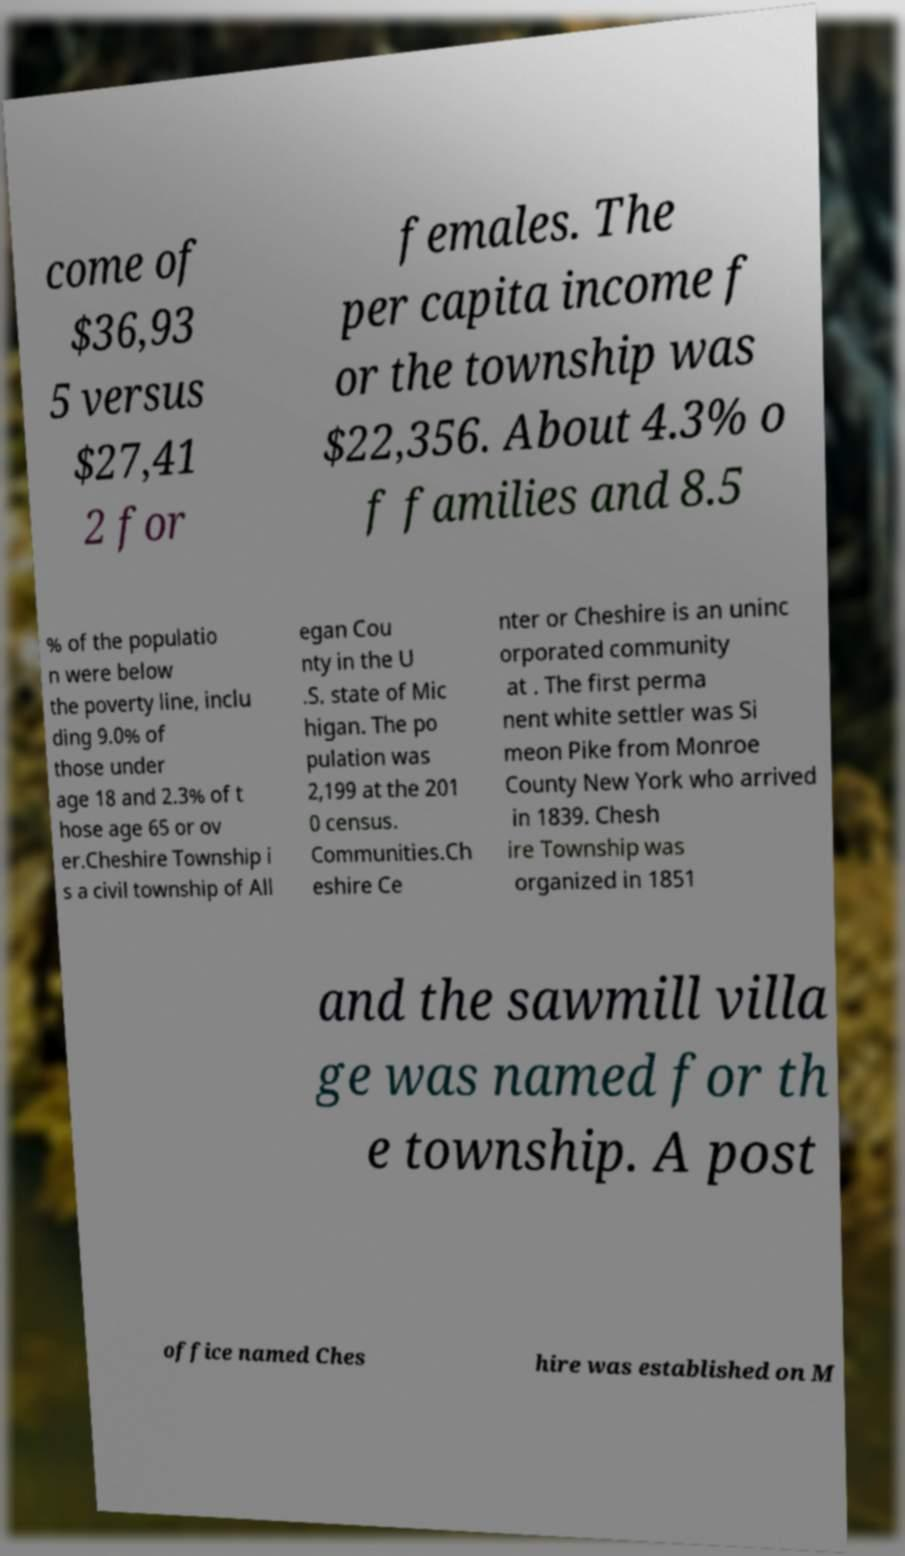I need the written content from this picture converted into text. Can you do that? come of $36,93 5 versus $27,41 2 for females. The per capita income f or the township was $22,356. About 4.3% o f families and 8.5 % of the populatio n were below the poverty line, inclu ding 9.0% of those under age 18 and 2.3% of t hose age 65 or ov er.Cheshire Township i s a civil township of All egan Cou nty in the U .S. state of Mic higan. The po pulation was 2,199 at the 201 0 census. Communities.Ch eshire Ce nter or Cheshire is an uninc orporated community at . The first perma nent white settler was Si meon Pike from Monroe County New York who arrived in 1839. Chesh ire Township was organized in 1851 and the sawmill villa ge was named for th e township. A post office named Ches hire was established on M 